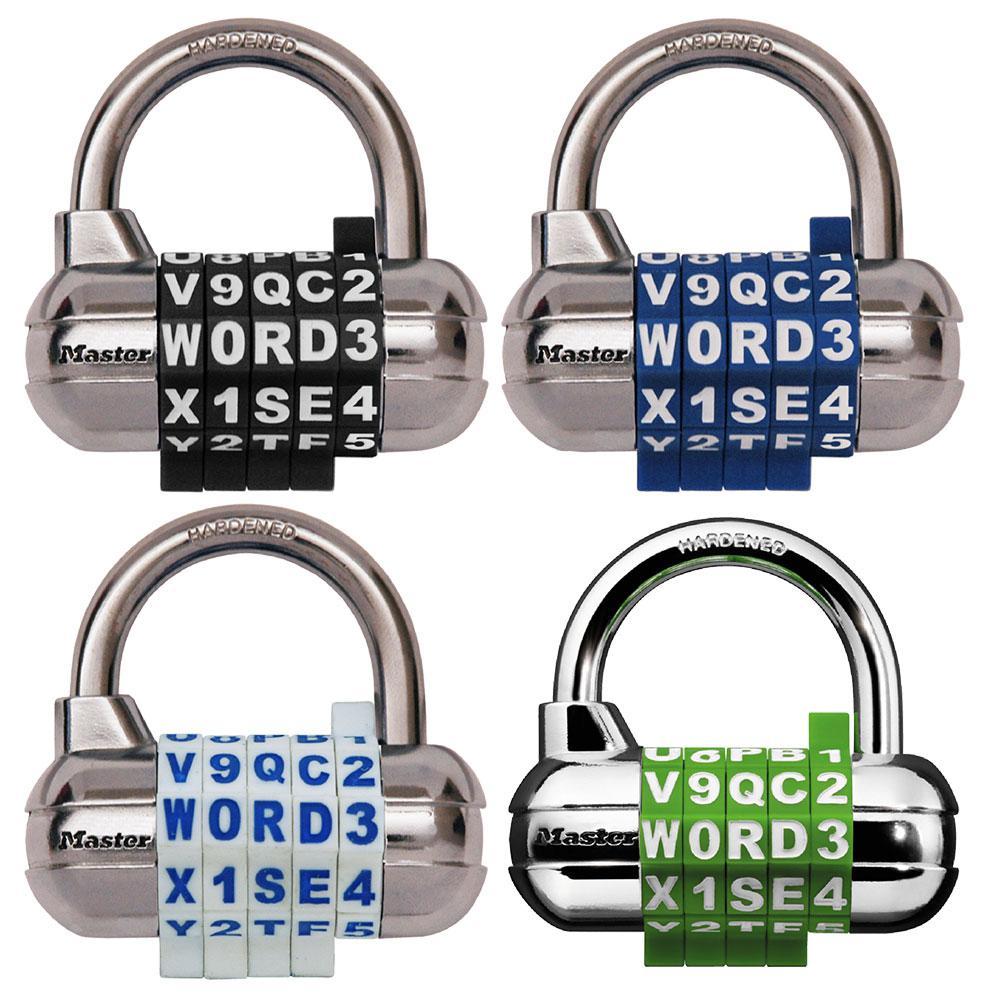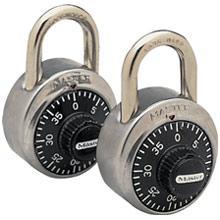The first image is the image on the left, the second image is the image on the right. For the images shown, is this caption "An image includes a capsule-shaped lock with a combination wheel containing white letters and numbers on black." true? Answer yes or no. Yes. The first image is the image on the left, the second image is the image on the right. Examine the images to the left and right. Is the description "There are at most 3 padlocks in total." accurate? Answer yes or no. No. 